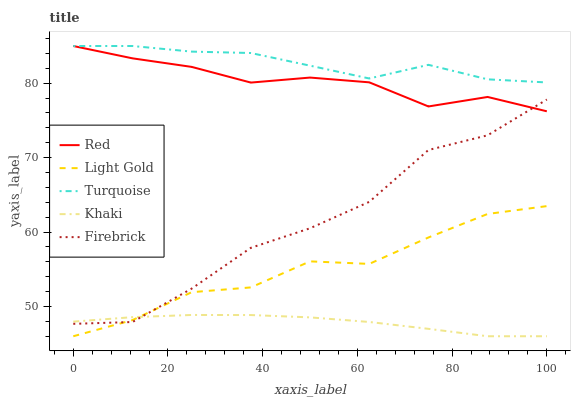Does Light Gold have the minimum area under the curve?
Answer yes or no. No. Does Light Gold have the maximum area under the curve?
Answer yes or no. No. Is Light Gold the smoothest?
Answer yes or no. No. Is Light Gold the roughest?
Answer yes or no. No. Does Firebrick have the lowest value?
Answer yes or no. No. Does Light Gold have the highest value?
Answer yes or no. No. Is Light Gold less than Turquoise?
Answer yes or no. Yes. Is Turquoise greater than Light Gold?
Answer yes or no. Yes. Does Light Gold intersect Turquoise?
Answer yes or no. No. 